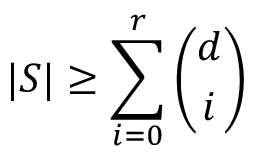<formula> <loc_0><loc_0><loc_500><loc_500>| S | \geq \sum _ { i = 0 } ^ { r } { \binom { d } { i } }</formula> 